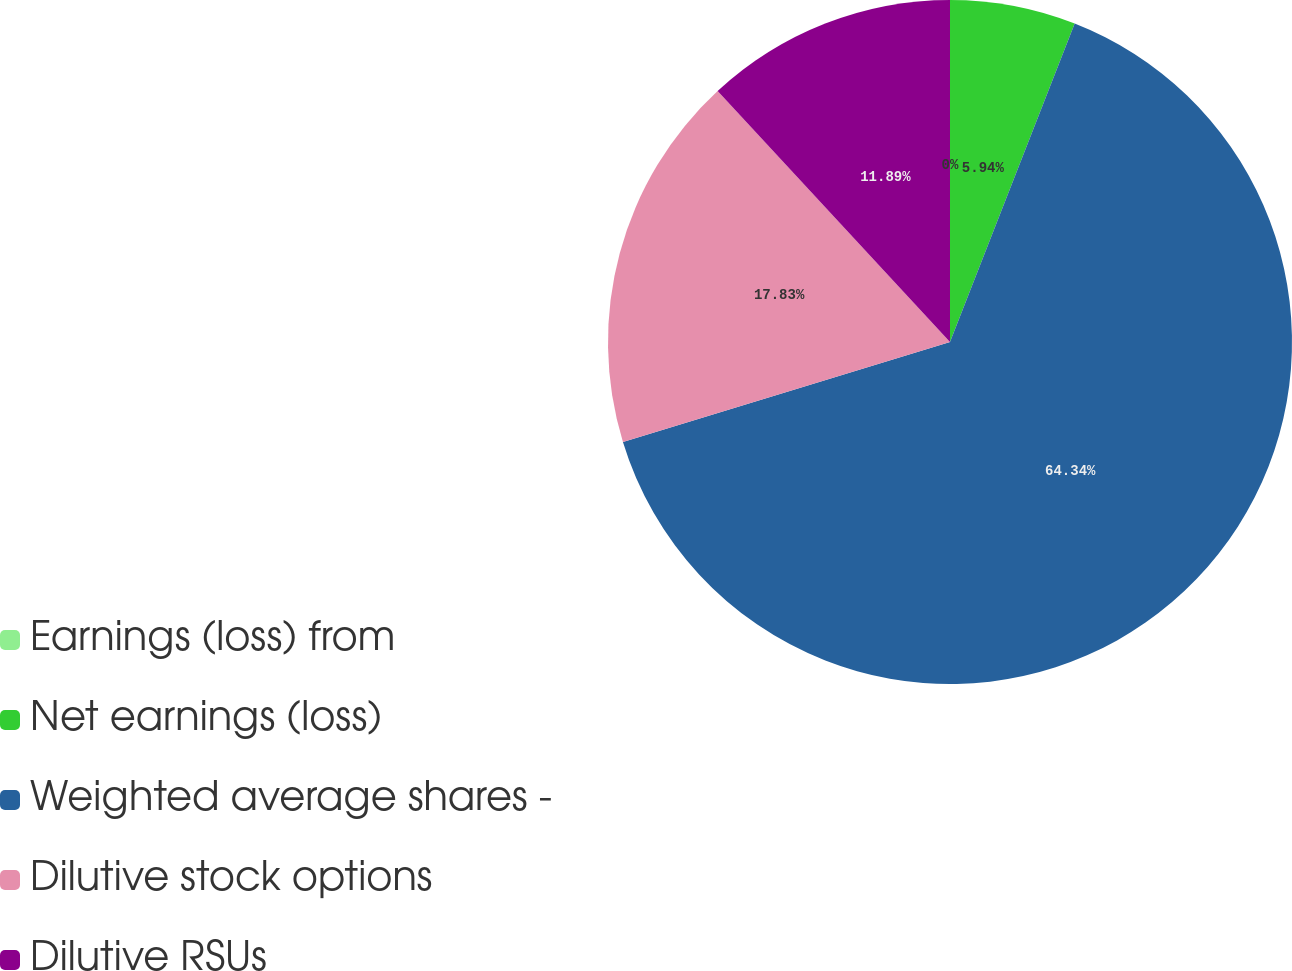Convert chart. <chart><loc_0><loc_0><loc_500><loc_500><pie_chart><fcel>Earnings (loss) from<fcel>Net earnings (loss)<fcel>Weighted average shares -<fcel>Dilutive stock options<fcel>Dilutive RSUs<nl><fcel>0.0%<fcel>5.94%<fcel>64.34%<fcel>17.83%<fcel>11.89%<nl></chart> 